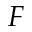Convert formula to latex. <formula><loc_0><loc_0><loc_500><loc_500>F</formula> 